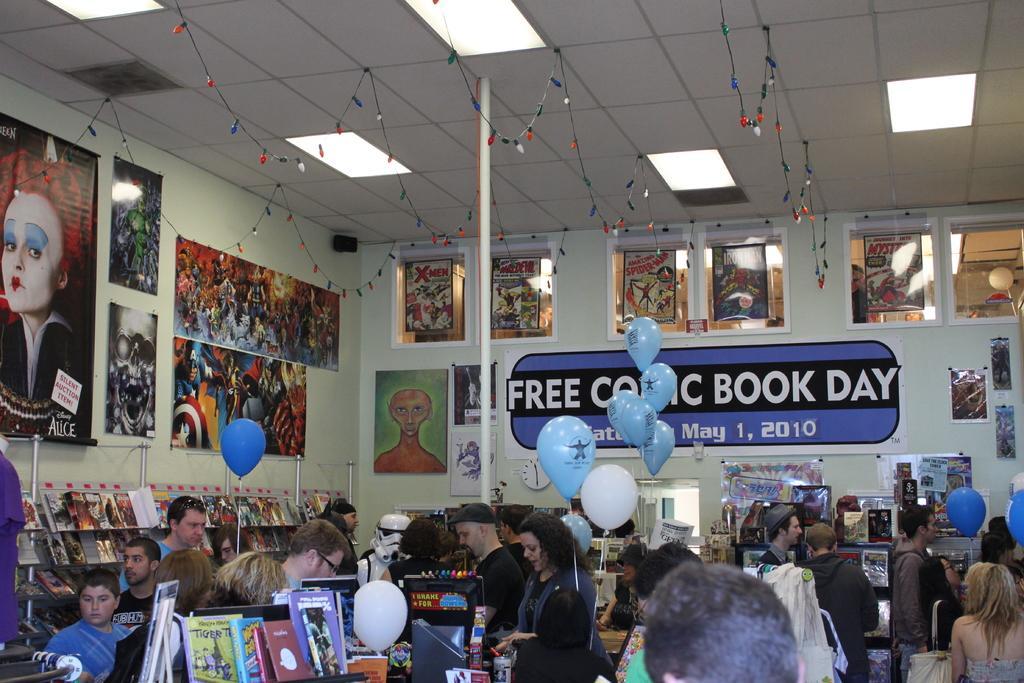Describe this image in one or two sentences. In this image I can see number of persons are standing on the floor and in front of them I can see few books, few balloons which are white and blue in color and in the background I can see the wall, few posters attached to the wall, a banner, the ceiling and few lights to the ceiling. 